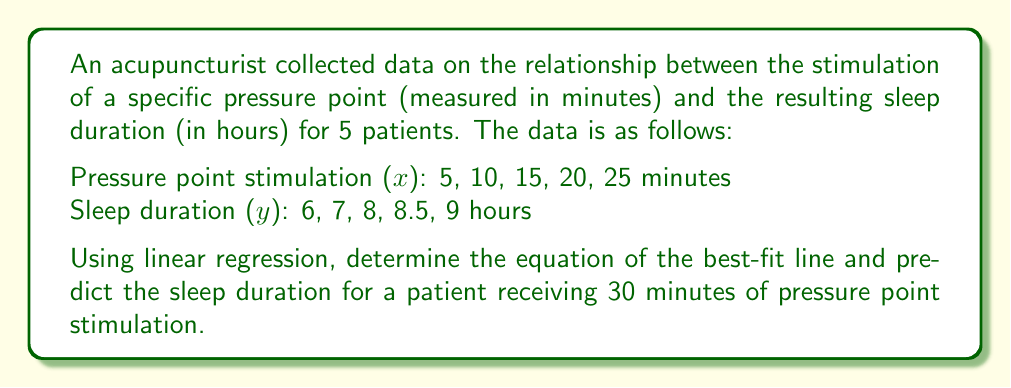Help me with this question. To solve this problem, we'll use linear regression to find the best-fit line equation $y = mx + b$, where $m$ is the slope and $b$ is the y-intercept.

Step 1: Calculate the means of x and y
$\bar{x} = \frac{5 + 10 + 15 + 20 + 25}{5} = 15$
$\bar{y} = \frac{6 + 7 + 8 + 8.5 + 9}{5} = 7.7$

Step 2: Calculate the slope (m)
$$m = \frac{\sum(x_i - \bar{x})(y_i - \bar{y})}{\sum(x_i - \bar{x})^2}$$

Numerator: $(-10)(-1.7) + (-5)(-0.7) + (0)(0.3) + (5)(0.8) + (10)(1.3) = 17 + 3.5 + 0 + 4 + 13 = 37.5$
Denominator: $(-10)^2 + (-5)^2 + (0)^2 + (5)^2 + (10)^2 = 100 + 25 + 0 + 25 + 100 = 250$

$m = \frac{37.5}{250} = 0.15$

Step 3: Calculate the y-intercept (b)
$b = \bar{y} - m\bar{x} = 7.7 - 0.15(15) = 5.45$

Step 4: Write the equation of the best-fit line
$y = 0.15x + 5.45$

Step 5: Predict sleep duration for 30 minutes of stimulation
$y = 0.15(30) + 5.45 = 4.5 + 5.45 = 9.95$

Therefore, the predicted sleep duration for a patient receiving 30 minutes of pressure point stimulation is 9.95 hours.
Answer: $y = 0.15x + 5.45$; 9.95 hours 